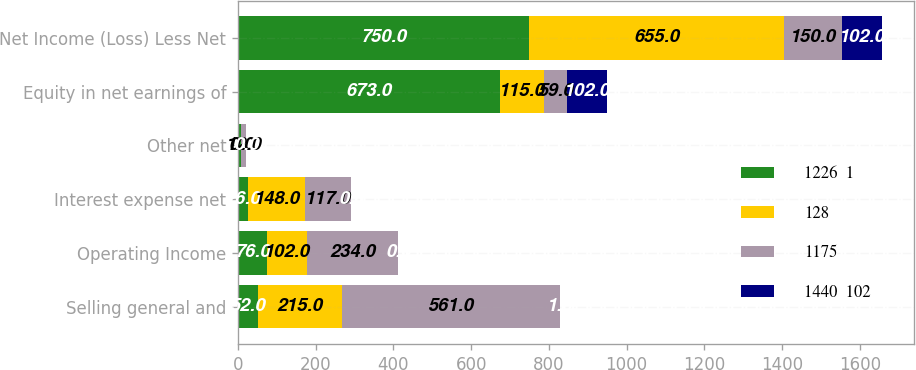Convert chart. <chart><loc_0><loc_0><loc_500><loc_500><stacked_bar_chart><ecel><fcel>Selling general and<fcel>Operating Income<fcel>Interest expense net<fcel>Other net<fcel>Equity in net earnings of<fcel>Net Income (Loss) Less Net<nl><fcel>1226  1<fcel>52<fcel>76<fcel>26<fcel>9<fcel>673<fcel>750<nl><fcel>128<fcel>215<fcel>102<fcel>148<fcel>0<fcel>115<fcel>655<nl><fcel>1175<fcel>561<fcel>234<fcel>117<fcel>12<fcel>59<fcel>150<nl><fcel>1440  102<fcel>1<fcel>0<fcel>0<fcel>0<fcel>102<fcel>102<nl></chart> 